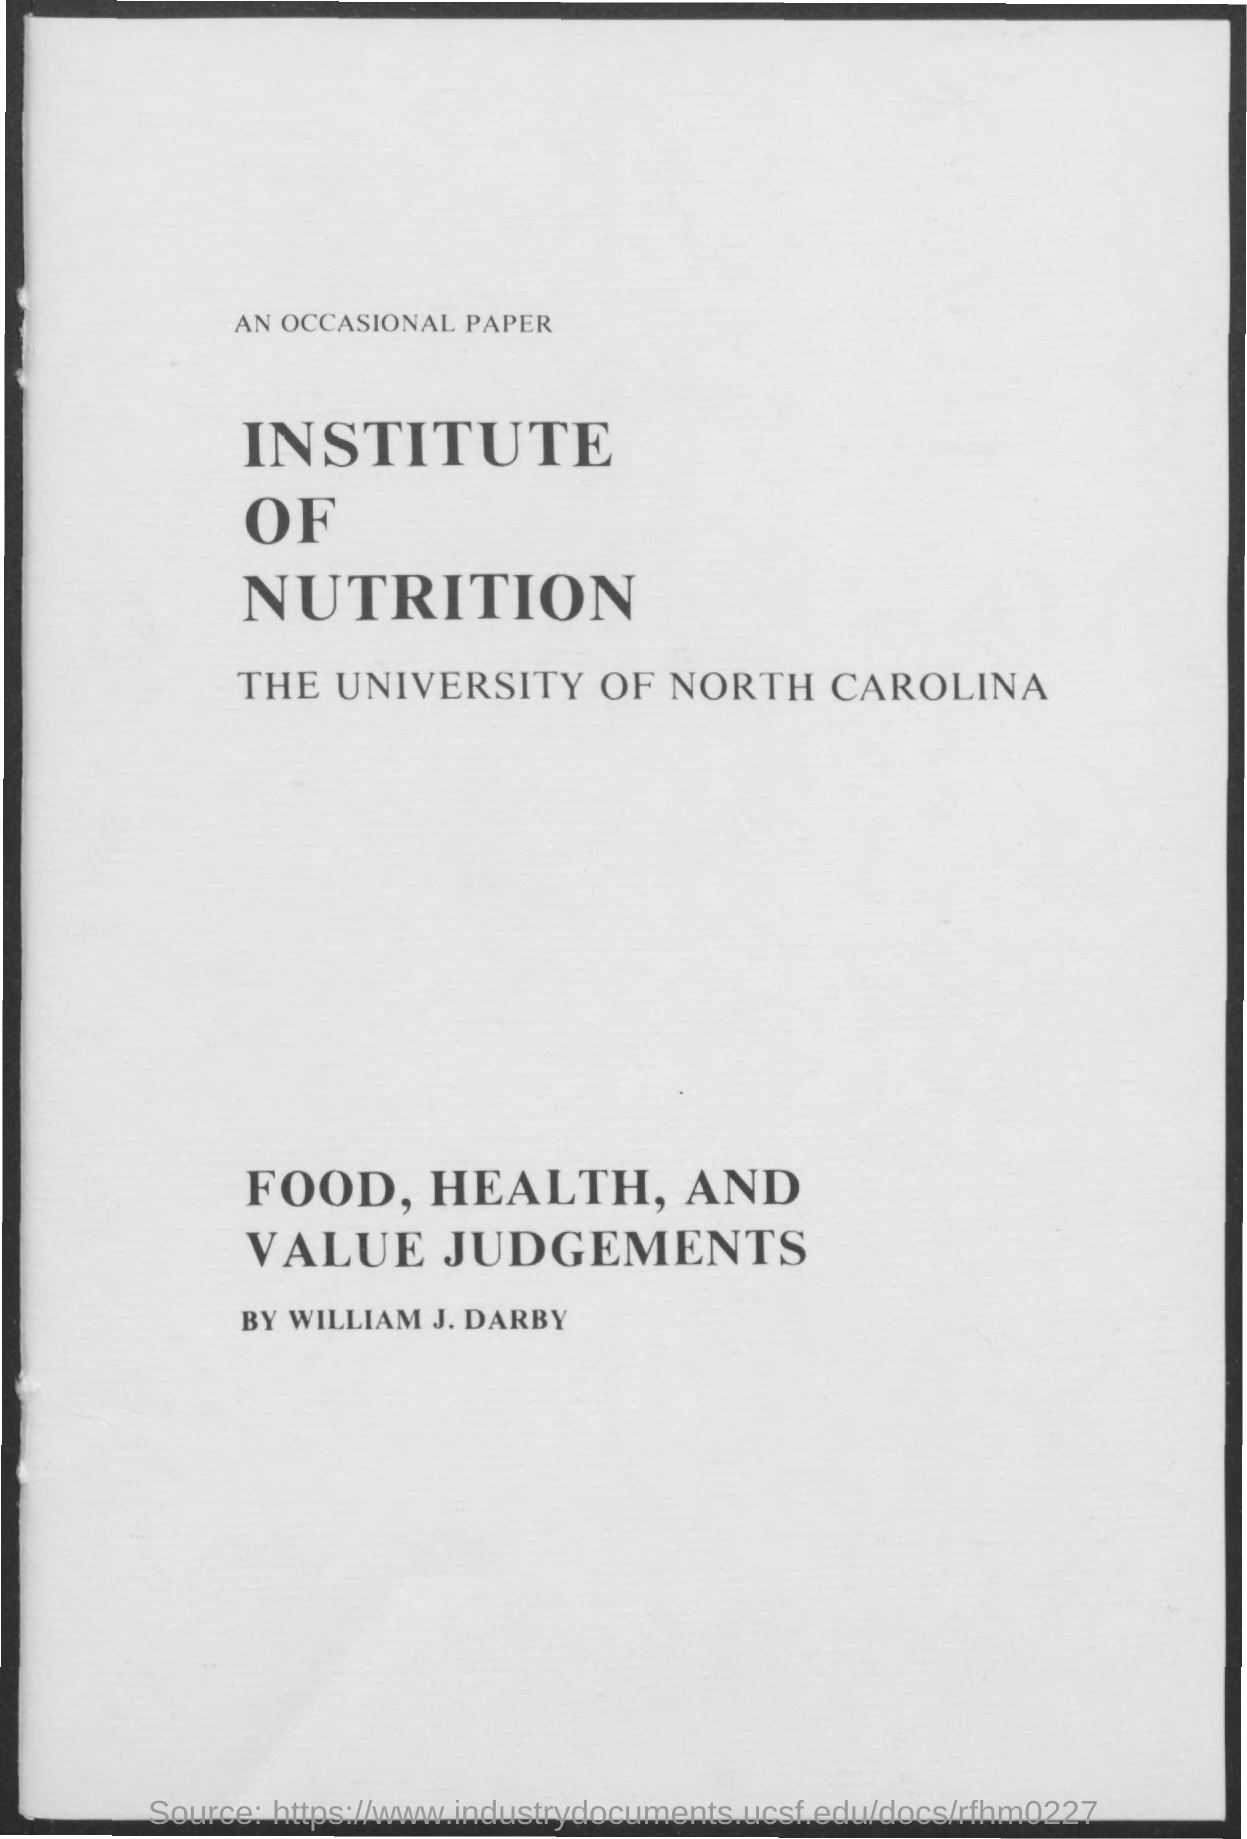What is the name of the university mentioned ?
Ensure brevity in your answer.  The university of north carolina. What is the institute mentioned ?
Keep it short and to the point. Institute of nutrition. 